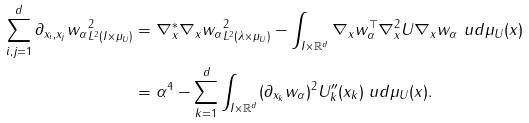<formula> <loc_0><loc_0><loc_500><loc_500>\sum _ { i , j = 1 } ^ { d } \| \partial _ { x _ { i } , x _ { j } } w _ { \alpha } \| _ { L ^ { 2 } ( I \times \mu _ { U } ) } ^ { 2 } & = \| \nabla _ { x } ^ { * } \nabla _ { x } w _ { \alpha } \| _ { L ^ { 2 } ( \lambda \times \mu _ { U } ) } ^ { 2 } - \int _ { I \times \mathbb { R } ^ { d } } \nabla _ { x } w _ { \alpha } ^ { \top } \nabla _ { x } ^ { 2 } U \nabla _ { x } w _ { \alpha } \ u d \mu _ { U } ( x ) \\ & = \alpha ^ { 4 } - \sum _ { k = 1 } ^ { d } \int _ { I \times \mathbb { R } ^ { d } } ( \partial _ { x _ { k } } w _ { \alpha } ) ^ { 2 } U _ { k } ^ { \prime \prime } ( x _ { k } ) \ u d \mu _ { U } ( x ) .</formula> 